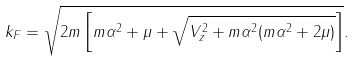Convert formula to latex. <formula><loc_0><loc_0><loc_500><loc_500>k _ { F } = \sqrt { 2 m \left [ m \alpha ^ { 2 } + \mu + \sqrt { V _ { z } ^ { 2 } + m \alpha ^ { 2 } ( m \alpha ^ { 2 } + 2 \mu ) } \right ] } .</formula> 